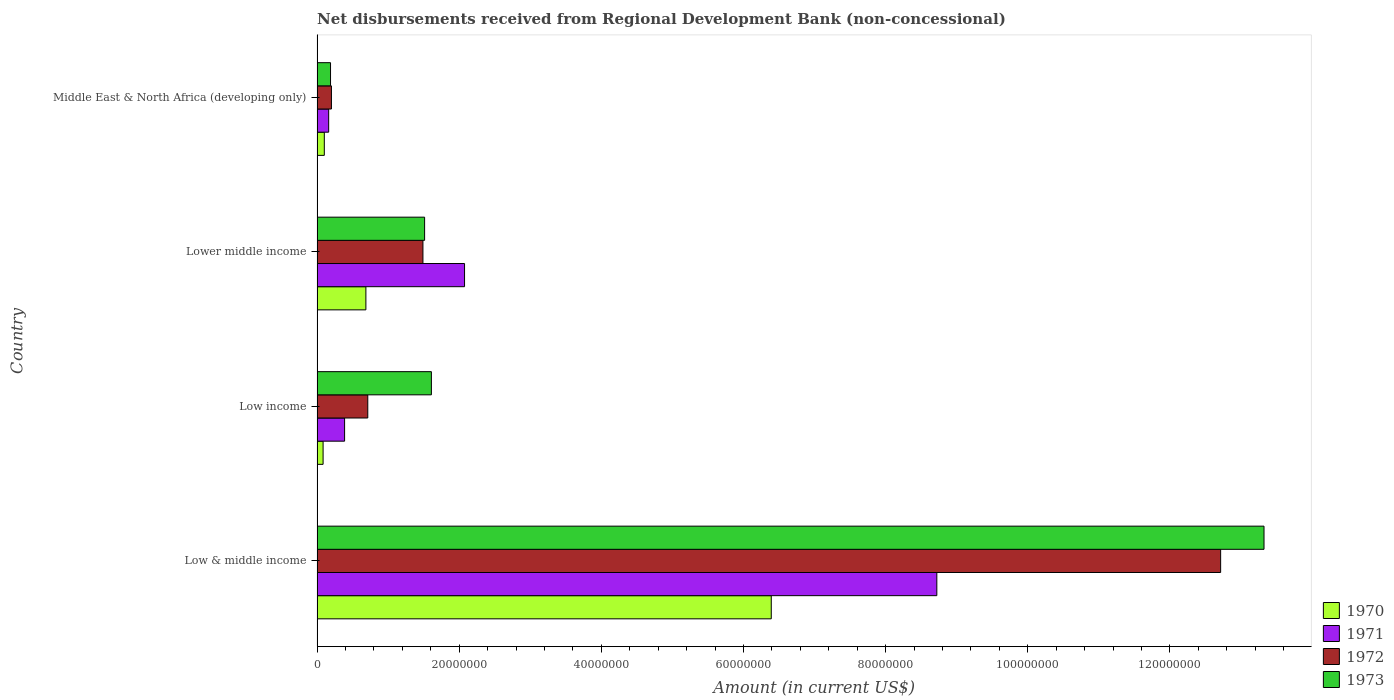How many different coloured bars are there?
Ensure brevity in your answer.  4. Are the number of bars on each tick of the Y-axis equal?
Make the answer very short. Yes. How many bars are there on the 4th tick from the bottom?
Provide a short and direct response. 4. In how many cases, is the number of bars for a given country not equal to the number of legend labels?
Your response must be concise. 0. What is the amount of disbursements received from Regional Development Bank in 1970 in Low income?
Offer a very short reply. 8.50e+05. Across all countries, what is the maximum amount of disbursements received from Regional Development Bank in 1972?
Your response must be concise. 1.27e+08. Across all countries, what is the minimum amount of disbursements received from Regional Development Bank in 1972?
Make the answer very short. 2.02e+06. In which country was the amount of disbursements received from Regional Development Bank in 1972 maximum?
Keep it short and to the point. Low & middle income. In which country was the amount of disbursements received from Regional Development Bank in 1972 minimum?
Provide a succinct answer. Middle East & North Africa (developing only). What is the total amount of disbursements received from Regional Development Bank in 1973 in the graph?
Offer a terse response. 1.66e+08. What is the difference between the amount of disbursements received from Regional Development Bank in 1970 in Low income and that in Middle East & North Africa (developing only)?
Your response must be concise. -1.71e+05. What is the difference between the amount of disbursements received from Regional Development Bank in 1973 in Lower middle income and the amount of disbursements received from Regional Development Bank in 1970 in Low & middle income?
Your response must be concise. -4.88e+07. What is the average amount of disbursements received from Regional Development Bank in 1973 per country?
Keep it short and to the point. 4.16e+07. What is the difference between the amount of disbursements received from Regional Development Bank in 1971 and amount of disbursements received from Regional Development Bank in 1970 in Low income?
Give a very brief answer. 3.02e+06. What is the ratio of the amount of disbursements received from Regional Development Bank in 1971 in Low income to that in Lower middle income?
Give a very brief answer. 0.19. Is the amount of disbursements received from Regional Development Bank in 1970 in Low & middle income less than that in Middle East & North Africa (developing only)?
Provide a succinct answer. No. What is the difference between the highest and the second highest amount of disbursements received from Regional Development Bank in 1973?
Offer a very short reply. 1.17e+08. What is the difference between the highest and the lowest amount of disbursements received from Regional Development Bank in 1971?
Keep it short and to the point. 8.56e+07. What does the 2nd bar from the bottom in Low income represents?
Your response must be concise. 1971. Is it the case that in every country, the sum of the amount of disbursements received from Regional Development Bank in 1973 and amount of disbursements received from Regional Development Bank in 1972 is greater than the amount of disbursements received from Regional Development Bank in 1970?
Your response must be concise. Yes. How many countries are there in the graph?
Offer a terse response. 4. What is the difference between two consecutive major ticks on the X-axis?
Offer a very short reply. 2.00e+07. Are the values on the major ticks of X-axis written in scientific E-notation?
Offer a very short reply. No. Does the graph contain grids?
Give a very brief answer. No. How are the legend labels stacked?
Your answer should be compact. Vertical. What is the title of the graph?
Make the answer very short. Net disbursements received from Regional Development Bank (non-concessional). What is the label or title of the X-axis?
Your answer should be compact. Amount (in current US$). What is the label or title of the Y-axis?
Your answer should be very brief. Country. What is the Amount (in current US$) of 1970 in Low & middle income?
Your answer should be very brief. 6.39e+07. What is the Amount (in current US$) of 1971 in Low & middle income?
Make the answer very short. 8.72e+07. What is the Amount (in current US$) of 1972 in Low & middle income?
Provide a succinct answer. 1.27e+08. What is the Amount (in current US$) in 1973 in Low & middle income?
Your answer should be very brief. 1.33e+08. What is the Amount (in current US$) of 1970 in Low income?
Give a very brief answer. 8.50e+05. What is the Amount (in current US$) of 1971 in Low income?
Keep it short and to the point. 3.88e+06. What is the Amount (in current US$) in 1972 in Low income?
Provide a succinct answer. 7.14e+06. What is the Amount (in current US$) in 1973 in Low income?
Your answer should be very brief. 1.61e+07. What is the Amount (in current US$) of 1970 in Lower middle income?
Make the answer very short. 6.87e+06. What is the Amount (in current US$) of 1971 in Lower middle income?
Provide a succinct answer. 2.08e+07. What is the Amount (in current US$) of 1972 in Lower middle income?
Keep it short and to the point. 1.49e+07. What is the Amount (in current US$) in 1973 in Lower middle income?
Ensure brevity in your answer.  1.51e+07. What is the Amount (in current US$) of 1970 in Middle East & North Africa (developing only)?
Ensure brevity in your answer.  1.02e+06. What is the Amount (in current US$) of 1971 in Middle East & North Africa (developing only)?
Provide a short and direct response. 1.64e+06. What is the Amount (in current US$) in 1972 in Middle East & North Africa (developing only)?
Your answer should be compact. 2.02e+06. What is the Amount (in current US$) in 1973 in Middle East & North Africa (developing only)?
Your answer should be very brief. 1.90e+06. Across all countries, what is the maximum Amount (in current US$) of 1970?
Offer a terse response. 6.39e+07. Across all countries, what is the maximum Amount (in current US$) of 1971?
Your answer should be compact. 8.72e+07. Across all countries, what is the maximum Amount (in current US$) of 1972?
Your answer should be compact. 1.27e+08. Across all countries, what is the maximum Amount (in current US$) of 1973?
Keep it short and to the point. 1.33e+08. Across all countries, what is the minimum Amount (in current US$) of 1970?
Your answer should be very brief. 8.50e+05. Across all countries, what is the minimum Amount (in current US$) of 1971?
Give a very brief answer. 1.64e+06. Across all countries, what is the minimum Amount (in current US$) of 1972?
Your answer should be compact. 2.02e+06. Across all countries, what is the minimum Amount (in current US$) in 1973?
Make the answer very short. 1.90e+06. What is the total Amount (in current US$) in 1970 in the graph?
Ensure brevity in your answer.  7.26e+07. What is the total Amount (in current US$) of 1971 in the graph?
Give a very brief answer. 1.13e+08. What is the total Amount (in current US$) of 1972 in the graph?
Your answer should be compact. 1.51e+08. What is the total Amount (in current US$) in 1973 in the graph?
Keep it short and to the point. 1.66e+08. What is the difference between the Amount (in current US$) of 1970 in Low & middle income and that in Low income?
Provide a short and direct response. 6.31e+07. What is the difference between the Amount (in current US$) of 1971 in Low & middle income and that in Low income?
Your answer should be very brief. 8.33e+07. What is the difference between the Amount (in current US$) of 1972 in Low & middle income and that in Low income?
Give a very brief answer. 1.20e+08. What is the difference between the Amount (in current US$) of 1973 in Low & middle income and that in Low income?
Make the answer very short. 1.17e+08. What is the difference between the Amount (in current US$) of 1970 in Low & middle income and that in Lower middle income?
Your answer should be compact. 5.70e+07. What is the difference between the Amount (in current US$) in 1971 in Low & middle income and that in Lower middle income?
Offer a very short reply. 6.64e+07. What is the difference between the Amount (in current US$) in 1972 in Low & middle income and that in Lower middle income?
Make the answer very short. 1.12e+08. What is the difference between the Amount (in current US$) in 1973 in Low & middle income and that in Lower middle income?
Your answer should be very brief. 1.18e+08. What is the difference between the Amount (in current US$) of 1970 in Low & middle income and that in Middle East & North Africa (developing only)?
Give a very brief answer. 6.29e+07. What is the difference between the Amount (in current US$) of 1971 in Low & middle income and that in Middle East & North Africa (developing only)?
Provide a succinct answer. 8.56e+07. What is the difference between the Amount (in current US$) in 1972 in Low & middle income and that in Middle East & North Africa (developing only)?
Offer a very short reply. 1.25e+08. What is the difference between the Amount (in current US$) in 1973 in Low & middle income and that in Middle East & North Africa (developing only)?
Provide a succinct answer. 1.31e+08. What is the difference between the Amount (in current US$) in 1970 in Low income and that in Lower middle income?
Provide a short and direct response. -6.02e+06. What is the difference between the Amount (in current US$) in 1971 in Low income and that in Lower middle income?
Keep it short and to the point. -1.69e+07. What is the difference between the Amount (in current US$) in 1972 in Low income and that in Lower middle income?
Give a very brief answer. -7.76e+06. What is the difference between the Amount (in current US$) of 1973 in Low income and that in Lower middle income?
Your answer should be compact. 9.55e+05. What is the difference between the Amount (in current US$) of 1970 in Low income and that in Middle East & North Africa (developing only)?
Give a very brief answer. -1.71e+05. What is the difference between the Amount (in current US$) in 1971 in Low income and that in Middle East & North Africa (developing only)?
Ensure brevity in your answer.  2.24e+06. What is the difference between the Amount (in current US$) in 1972 in Low income and that in Middle East & North Africa (developing only)?
Ensure brevity in your answer.  5.11e+06. What is the difference between the Amount (in current US$) of 1973 in Low income and that in Middle East & North Africa (developing only)?
Offer a very short reply. 1.42e+07. What is the difference between the Amount (in current US$) in 1970 in Lower middle income and that in Middle East & North Africa (developing only)?
Keep it short and to the point. 5.85e+06. What is the difference between the Amount (in current US$) of 1971 in Lower middle income and that in Middle East & North Africa (developing only)?
Provide a short and direct response. 1.91e+07. What is the difference between the Amount (in current US$) in 1972 in Lower middle income and that in Middle East & North Africa (developing only)?
Provide a succinct answer. 1.29e+07. What is the difference between the Amount (in current US$) in 1973 in Lower middle income and that in Middle East & North Africa (developing only)?
Your answer should be very brief. 1.32e+07. What is the difference between the Amount (in current US$) of 1970 in Low & middle income and the Amount (in current US$) of 1971 in Low income?
Provide a short and direct response. 6.00e+07. What is the difference between the Amount (in current US$) in 1970 in Low & middle income and the Amount (in current US$) in 1972 in Low income?
Keep it short and to the point. 5.68e+07. What is the difference between the Amount (in current US$) of 1970 in Low & middle income and the Amount (in current US$) of 1973 in Low income?
Offer a very short reply. 4.78e+07. What is the difference between the Amount (in current US$) of 1971 in Low & middle income and the Amount (in current US$) of 1972 in Low income?
Your answer should be compact. 8.01e+07. What is the difference between the Amount (in current US$) in 1971 in Low & middle income and the Amount (in current US$) in 1973 in Low income?
Your answer should be compact. 7.11e+07. What is the difference between the Amount (in current US$) in 1972 in Low & middle income and the Amount (in current US$) in 1973 in Low income?
Your answer should be compact. 1.11e+08. What is the difference between the Amount (in current US$) in 1970 in Low & middle income and the Amount (in current US$) in 1971 in Lower middle income?
Offer a terse response. 4.32e+07. What is the difference between the Amount (in current US$) in 1970 in Low & middle income and the Amount (in current US$) in 1972 in Lower middle income?
Offer a very short reply. 4.90e+07. What is the difference between the Amount (in current US$) in 1970 in Low & middle income and the Amount (in current US$) in 1973 in Lower middle income?
Provide a succinct answer. 4.88e+07. What is the difference between the Amount (in current US$) in 1971 in Low & middle income and the Amount (in current US$) in 1972 in Lower middle income?
Offer a terse response. 7.23e+07. What is the difference between the Amount (in current US$) in 1971 in Low & middle income and the Amount (in current US$) in 1973 in Lower middle income?
Offer a very short reply. 7.21e+07. What is the difference between the Amount (in current US$) in 1972 in Low & middle income and the Amount (in current US$) in 1973 in Lower middle income?
Make the answer very short. 1.12e+08. What is the difference between the Amount (in current US$) in 1970 in Low & middle income and the Amount (in current US$) in 1971 in Middle East & North Africa (developing only)?
Your response must be concise. 6.23e+07. What is the difference between the Amount (in current US$) in 1970 in Low & middle income and the Amount (in current US$) in 1972 in Middle East & North Africa (developing only)?
Provide a succinct answer. 6.19e+07. What is the difference between the Amount (in current US$) in 1970 in Low & middle income and the Amount (in current US$) in 1973 in Middle East & North Africa (developing only)?
Provide a succinct answer. 6.20e+07. What is the difference between the Amount (in current US$) in 1971 in Low & middle income and the Amount (in current US$) in 1972 in Middle East & North Africa (developing only)?
Your answer should be very brief. 8.52e+07. What is the difference between the Amount (in current US$) in 1971 in Low & middle income and the Amount (in current US$) in 1973 in Middle East & North Africa (developing only)?
Keep it short and to the point. 8.53e+07. What is the difference between the Amount (in current US$) of 1972 in Low & middle income and the Amount (in current US$) of 1973 in Middle East & North Africa (developing only)?
Make the answer very short. 1.25e+08. What is the difference between the Amount (in current US$) of 1970 in Low income and the Amount (in current US$) of 1971 in Lower middle income?
Give a very brief answer. -1.99e+07. What is the difference between the Amount (in current US$) in 1970 in Low income and the Amount (in current US$) in 1972 in Lower middle income?
Give a very brief answer. -1.40e+07. What is the difference between the Amount (in current US$) of 1970 in Low income and the Amount (in current US$) of 1973 in Lower middle income?
Ensure brevity in your answer.  -1.43e+07. What is the difference between the Amount (in current US$) of 1971 in Low income and the Amount (in current US$) of 1972 in Lower middle income?
Your answer should be compact. -1.10e+07. What is the difference between the Amount (in current US$) in 1971 in Low income and the Amount (in current US$) in 1973 in Lower middle income?
Ensure brevity in your answer.  -1.13e+07. What is the difference between the Amount (in current US$) of 1972 in Low income and the Amount (in current US$) of 1973 in Lower middle income?
Offer a very short reply. -8.00e+06. What is the difference between the Amount (in current US$) in 1970 in Low income and the Amount (in current US$) in 1971 in Middle East & North Africa (developing only)?
Offer a terse response. -7.85e+05. What is the difference between the Amount (in current US$) in 1970 in Low income and the Amount (in current US$) in 1972 in Middle East & North Africa (developing only)?
Give a very brief answer. -1.17e+06. What is the difference between the Amount (in current US$) of 1970 in Low income and the Amount (in current US$) of 1973 in Middle East & North Africa (developing only)?
Provide a succinct answer. -1.05e+06. What is the difference between the Amount (in current US$) in 1971 in Low income and the Amount (in current US$) in 1972 in Middle East & North Africa (developing only)?
Your answer should be very brief. 1.85e+06. What is the difference between the Amount (in current US$) of 1971 in Low income and the Amount (in current US$) of 1973 in Middle East & North Africa (developing only)?
Offer a very short reply. 1.98e+06. What is the difference between the Amount (in current US$) of 1972 in Low income and the Amount (in current US$) of 1973 in Middle East & North Africa (developing only)?
Provide a succinct answer. 5.24e+06. What is the difference between the Amount (in current US$) of 1970 in Lower middle income and the Amount (in current US$) of 1971 in Middle East & North Africa (developing only)?
Your answer should be very brief. 5.24e+06. What is the difference between the Amount (in current US$) in 1970 in Lower middle income and the Amount (in current US$) in 1972 in Middle East & North Africa (developing only)?
Keep it short and to the point. 4.85e+06. What is the difference between the Amount (in current US$) in 1970 in Lower middle income and the Amount (in current US$) in 1973 in Middle East & North Africa (developing only)?
Make the answer very short. 4.98e+06. What is the difference between the Amount (in current US$) of 1971 in Lower middle income and the Amount (in current US$) of 1972 in Middle East & North Africa (developing only)?
Provide a succinct answer. 1.87e+07. What is the difference between the Amount (in current US$) of 1971 in Lower middle income and the Amount (in current US$) of 1973 in Middle East & North Africa (developing only)?
Make the answer very short. 1.89e+07. What is the difference between the Amount (in current US$) of 1972 in Lower middle income and the Amount (in current US$) of 1973 in Middle East & North Africa (developing only)?
Give a very brief answer. 1.30e+07. What is the average Amount (in current US$) in 1970 per country?
Keep it short and to the point. 1.82e+07. What is the average Amount (in current US$) of 1971 per country?
Provide a succinct answer. 2.84e+07. What is the average Amount (in current US$) of 1972 per country?
Your answer should be compact. 3.78e+07. What is the average Amount (in current US$) of 1973 per country?
Provide a succinct answer. 4.16e+07. What is the difference between the Amount (in current US$) in 1970 and Amount (in current US$) in 1971 in Low & middle income?
Give a very brief answer. -2.33e+07. What is the difference between the Amount (in current US$) of 1970 and Amount (in current US$) of 1972 in Low & middle income?
Offer a terse response. -6.32e+07. What is the difference between the Amount (in current US$) in 1970 and Amount (in current US$) in 1973 in Low & middle income?
Your answer should be compact. -6.93e+07. What is the difference between the Amount (in current US$) in 1971 and Amount (in current US$) in 1972 in Low & middle income?
Your answer should be very brief. -3.99e+07. What is the difference between the Amount (in current US$) of 1971 and Amount (in current US$) of 1973 in Low & middle income?
Your response must be concise. -4.60e+07. What is the difference between the Amount (in current US$) of 1972 and Amount (in current US$) of 1973 in Low & middle income?
Give a very brief answer. -6.10e+06. What is the difference between the Amount (in current US$) in 1970 and Amount (in current US$) in 1971 in Low income?
Provide a succinct answer. -3.02e+06. What is the difference between the Amount (in current US$) of 1970 and Amount (in current US$) of 1972 in Low income?
Your answer should be very brief. -6.29e+06. What is the difference between the Amount (in current US$) in 1970 and Amount (in current US$) in 1973 in Low income?
Your response must be concise. -1.52e+07. What is the difference between the Amount (in current US$) in 1971 and Amount (in current US$) in 1972 in Low income?
Offer a terse response. -3.26e+06. What is the difference between the Amount (in current US$) in 1971 and Amount (in current US$) in 1973 in Low income?
Offer a terse response. -1.22e+07. What is the difference between the Amount (in current US$) of 1972 and Amount (in current US$) of 1973 in Low income?
Provide a succinct answer. -8.95e+06. What is the difference between the Amount (in current US$) of 1970 and Amount (in current US$) of 1971 in Lower middle income?
Your answer should be very brief. -1.39e+07. What is the difference between the Amount (in current US$) of 1970 and Amount (in current US$) of 1972 in Lower middle income?
Provide a short and direct response. -8.03e+06. What is the difference between the Amount (in current US$) of 1970 and Amount (in current US$) of 1973 in Lower middle income?
Keep it short and to the point. -8.26e+06. What is the difference between the Amount (in current US$) of 1971 and Amount (in current US$) of 1972 in Lower middle income?
Your answer should be compact. 5.85e+06. What is the difference between the Amount (in current US$) in 1971 and Amount (in current US$) in 1973 in Lower middle income?
Offer a very short reply. 5.62e+06. What is the difference between the Amount (in current US$) in 1972 and Amount (in current US$) in 1973 in Lower middle income?
Give a very brief answer. -2.36e+05. What is the difference between the Amount (in current US$) in 1970 and Amount (in current US$) in 1971 in Middle East & North Africa (developing only)?
Your answer should be compact. -6.14e+05. What is the difference between the Amount (in current US$) in 1970 and Amount (in current US$) in 1972 in Middle East & North Africa (developing only)?
Offer a very short reply. -1.00e+06. What is the difference between the Amount (in current US$) in 1970 and Amount (in current US$) in 1973 in Middle East & North Africa (developing only)?
Provide a short and direct response. -8.75e+05. What is the difference between the Amount (in current US$) of 1971 and Amount (in current US$) of 1972 in Middle East & North Africa (developing only)?
Your answer should be compact. -3.89e+05. What is the difference between the Amount (in current US$) of 1971 and Amount (in current US$) of 1973 in Middle East & North Africa (developing only)?
Ensure brevity in your answer.  -2.61e+05. What is the difference between the Amount (in current US$) of 1972 and Amount (in current US$) of 1973 in Middle East & North Africa (developing only)?
Keep it short and to the point. 1.28e+05. What is the ratio of the Amount (in current US$) in 1970 in Low & middle income to that in Low income?
Your answer should be compact. 75.18. What is the ratio of the Amount (in current US$) in 1971 in Low & middle income to that in Low income?
Provide a succinct answer. 22.5. What is the ratio of the Amount (in current US$) in 1972 in Low & middle income to that in Low income?
Your answer should be compact. 17.81. What is the ratio of the Amount (in current US$) of 1973 in Low & middle income to that in Low income?
Offer a terse response. 8.28. What is the ratio of the Amount (in current US$) of 1970 in Low & middle income to that in Lower middle income?
Keep it short and to the point. 9.3. What is the ratio of the Amount (in current US$) in 1971 in Low & middle income to that in Lower middle income?
Offer a very short reply. 4.2. What is the ratio of the Amount (in current US$) in 1972 in Low & middle income to that in Lower middle income?
Keep it short and to the point. 8.53. What is the ratio of the Amount (in current US$) in 1973 in Low & middle income to that in Lower middle income?
Make the answer very short. 8.8. What is the ratio of the Amount (in current US$) in 1970 in Low & middle income to that in Middle East & North Africa (developing only)?
Your answer should be compact. 62.59. What is the ratio of the Amount (in current US$) in 1971 in Low & middle income to that in Middle East & North Africa (developing only)?
Provide a short and direct response. 53.33. What is the ratio of the Amount (in current US$) of 1972 in Low & middle income to that in Middle East & North Africa (developing only)?
Give a very brief answer. 62.81. What is the ratio of the Amount (in current US$) of 1973 in Low & middle income to that in Middle East & North Africa (developing only)?
Offer a terse response. 70.27. What is the ratio of the Amount (in current US$) in 1970 in Low income to that in Lower middle income?
Keep it short and to the point. 0.12. What is the ratio of the Amount (in current US$) in 1971 in Low income to that in Lower middle income?
Your response must be concise. 0.19. What is the ratio of the Amount (in current US$) of 1972 in Low income to that in Lower middle income?
Offer a terse response. 0.48. What is the ratio of the Amount (in current US$) in 1973 in Low income to that in Lower middle income?
Give a very brief answer. 1.06. What is the ratio of the Amount (in current US$) of 1970 in Low income to that in Middle East & North Africa (developing only)?
Offer a very short reply. 0.83. What is the ratio of the Amount (in current US$) of 1971 in Low income to that in Middle East & North Africa (developing only)?
Ensure brevity in your answer.  2.37. What is the ratio of the Amount (in current US$) of 1972 in Low income to that in Middle East & North Africa (developing only)?
Your answer should be very brief. 3.53. What is the ratio of the Amount (in current US$) in 1973 in Low income to that in Middle East & North Africa (developing only)?
Provide a short and direct response. 8.49. What is the ratio of the Amount (in current US$) in 1970 in Lower middle income to that in Middle East & North Africa (developing only)?
Your answer should be very brief. 6.73. What is the ratio of the Amount (in current US$) of 1971 in Lower middle income to that in Middle East & North Africa (developing only)?
Provide a short and direct response. 12.69. What is the ratio of the Amount (in current US$) of 1972 in Lower middle income to that in Middle East & North Africa (developing only)?
Your response must be concise. 7.36. What is the ratio of the Amount (in current US$) in 1973 in Lower middle income to that in Middle East & North Africa (developing only)?
Your response must be concise. 7.98. What is the difference between the highest and the second highest Amount (in current US$) of 1970?
Offer a very short reply. 5.70e+07. What is the difference between the highest and the second highest Amount (in current US$) in 1971?
Offer a very short reply. 6.64e+07. What is the difference between the highest and the second highest Amount (in current US$) in 1972?
Keep it short and to the point. 1.12e+08. What is the difference between the highest and the second highest Amount (in current US$) of 1973?
Ensure brevity in your answer.  1.17e+08. What is the difference between the highest and the lowest Amount (in current US$) in 1970?
Offer a terse response. 6.31e+07. What is the difference between the highest and the lowest Amount (in current US$) in 1971?
Provide a short and direct response. 8.56e+07. What is the difference between the highest and the lowest Amount (in current US$) of 1972?
Your answer should be compact. 1.25e+08. What is the difference between the highest and the lowest Amount (in current US$) of 1973?
Provide a succinct answer. 1.31e+08. 